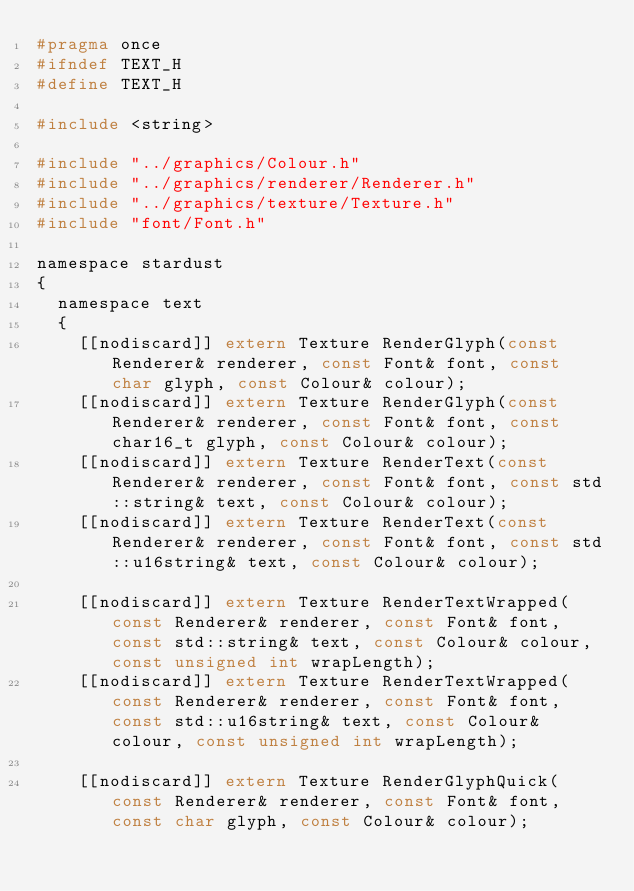<code> <loc_0><loc_0><loc_500><loc_500><_C_>#pragma once
#ifndef TEXT_H
#define TEXT_H

#include <string>

#include "../graphics/Colour.h"
#include "../graphics/renderer/Renderer.h"
#include "../graphics/texture/Texture.h"
#include "font/Font.h"

namespace stardust
{
	namespace text
	{
		[[nodiscard]] extern Texture RenderGlyph(const Renderer& renderer, const Font& font, const char glyph, const Colour& colour);
		[[nodiscard]] extern Texture RenderGlyph(const Renderer& renderer, const Font& font, const char16_t glyph, const Colour& colour);
		[[nodiscard]] extern Texture RenderText(const Renderer& renderer, const Font& font, const std::string& text, const Colour& colour);
		[[nodiscard]] extern Texture RenderText(const Renderer& renderer, const Font& font, const std::u16string& text, const Colour& colour);

		[[nodiscard]] extern Texture RenderTextWrapped(const Renderer& renderer, const Font& font, const std::string& text, const Colour& colour, const unsigned int wrapLength);
		[[nodiscard]] extern Texture RenderTextWrapped(const Renderer& renderer, const Font& font, const std::u16string& text, const Colour& colour, const unsigned int wrapLength);

		[[nodiscard]] extern Texture RenderGlyphQuick(const Renderer& renderer, const Font& font, const char glyph, const Colour& colour);</code> 